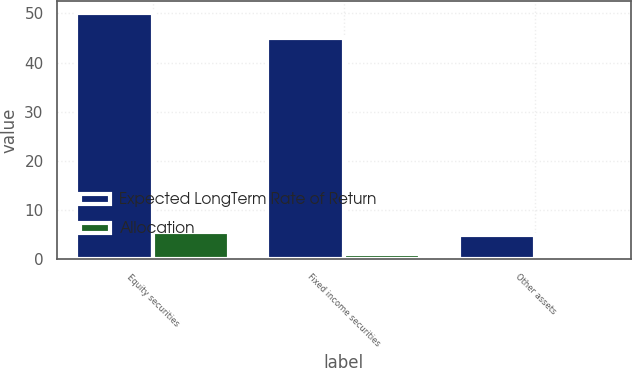Convert chart. <chart><loc_0><loc_0><loc_500><loc_500><stacked_bar_chart><ecel><fcel>Equity securities<fcel>Fixed income securities<fcel>Other assets<nl><fcel>Expected LongTerm Rate of Return<fcel>50<fcel>45<fcel>5<nl><fcel>Allocation<fcel>5.6<fcel>1.1<fcel>0.1<nl></chart> 